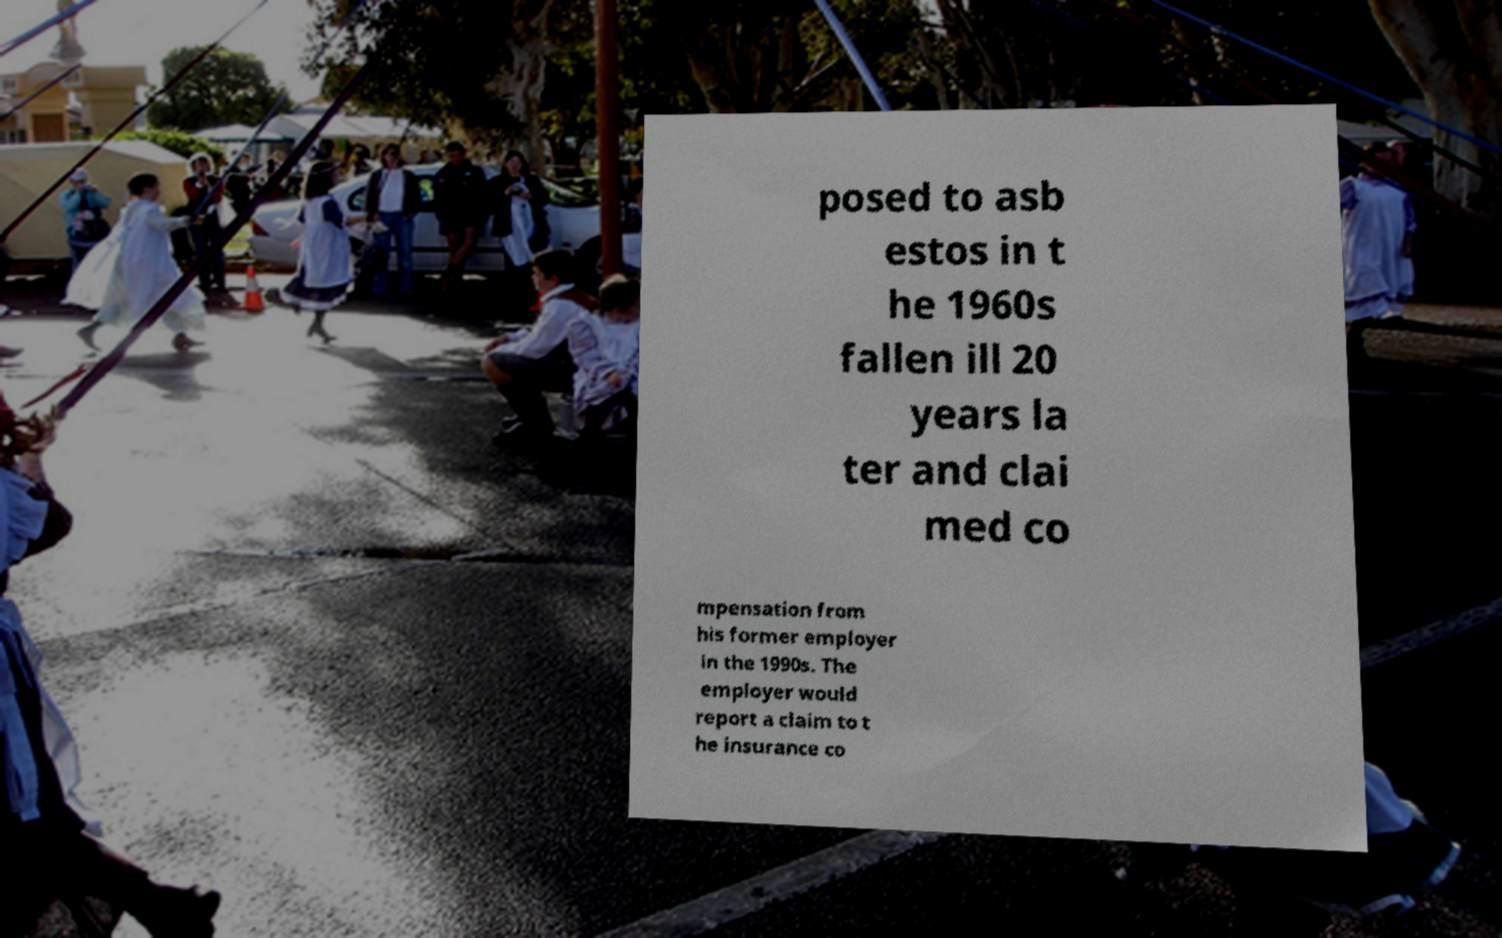I need the written content from this picture converted into text. Can you do that? posed to asb estos in t he 1960s fallen ill 20 years la ter and clai med co mpensation from his former employer in the 1990s. The employer would report a claim to t he insurance co 